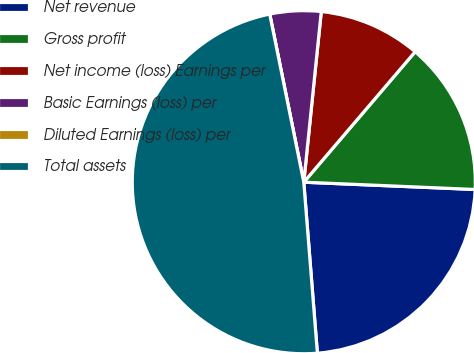Convert chart. <chart><loc_0><loc_0><loc_500><loc_500><pie_chart><fcel>Net revenue<fcel>Gross profit<fcel>Net income (loss) Earnings per<fcel>Basic Earnings (loss) per<fcel>Diluted Earnings (loss) per<fcel>Total assets<nl><fcel>23.06%<fcel>14.43%<fcel>9.62%<fcel>4.81%<fcel>0.0%<fcel>48.08%<nl></chart> 